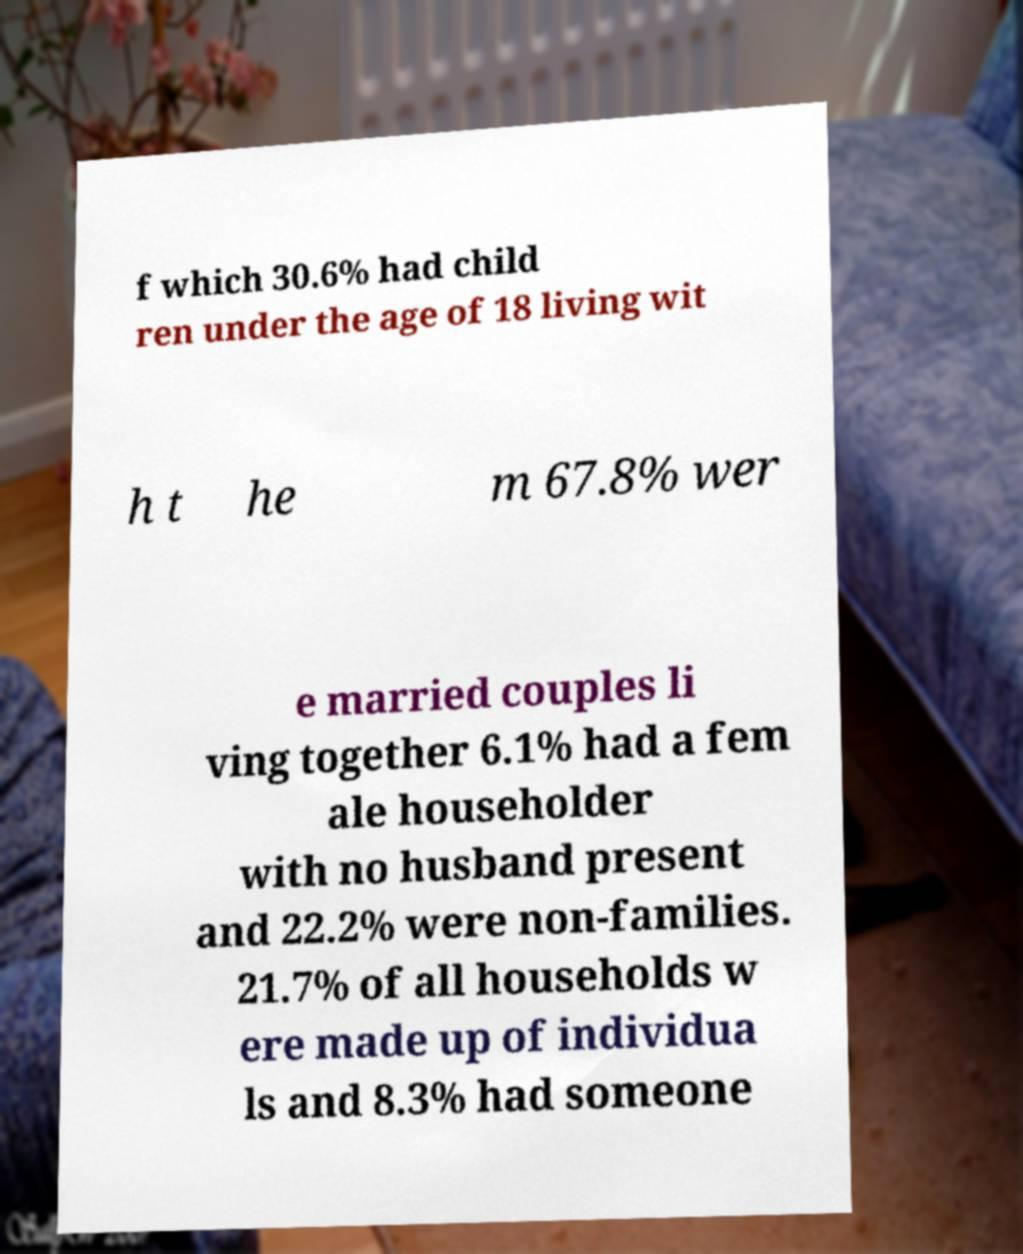Could you assist in decoding the text presented in this image and type it out clearly? f which 30.6% had child ren under the age of 18 living wit h t he m 67.8% wer e married couples li ving together 6.1% had a fem ale householder with no husband present and 22.2% were non-families. 21.7% of all households w ere made up of individua ls and 8.3% had someone 